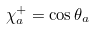<formula> <loc_0><loc_0><loc_500><loc_500>\chi _ { a } ^ { + } = \cos \theta _ { a }</formula> 